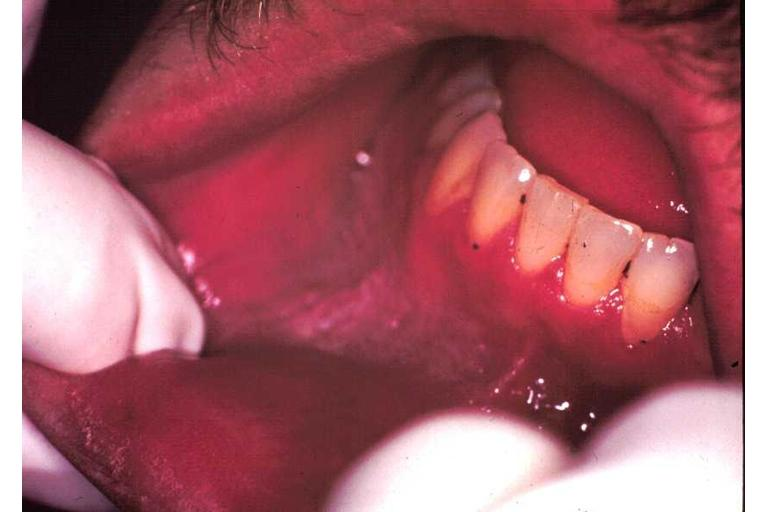what does this image show?
Answer the question using a single word or phrase. Leukoplakia 